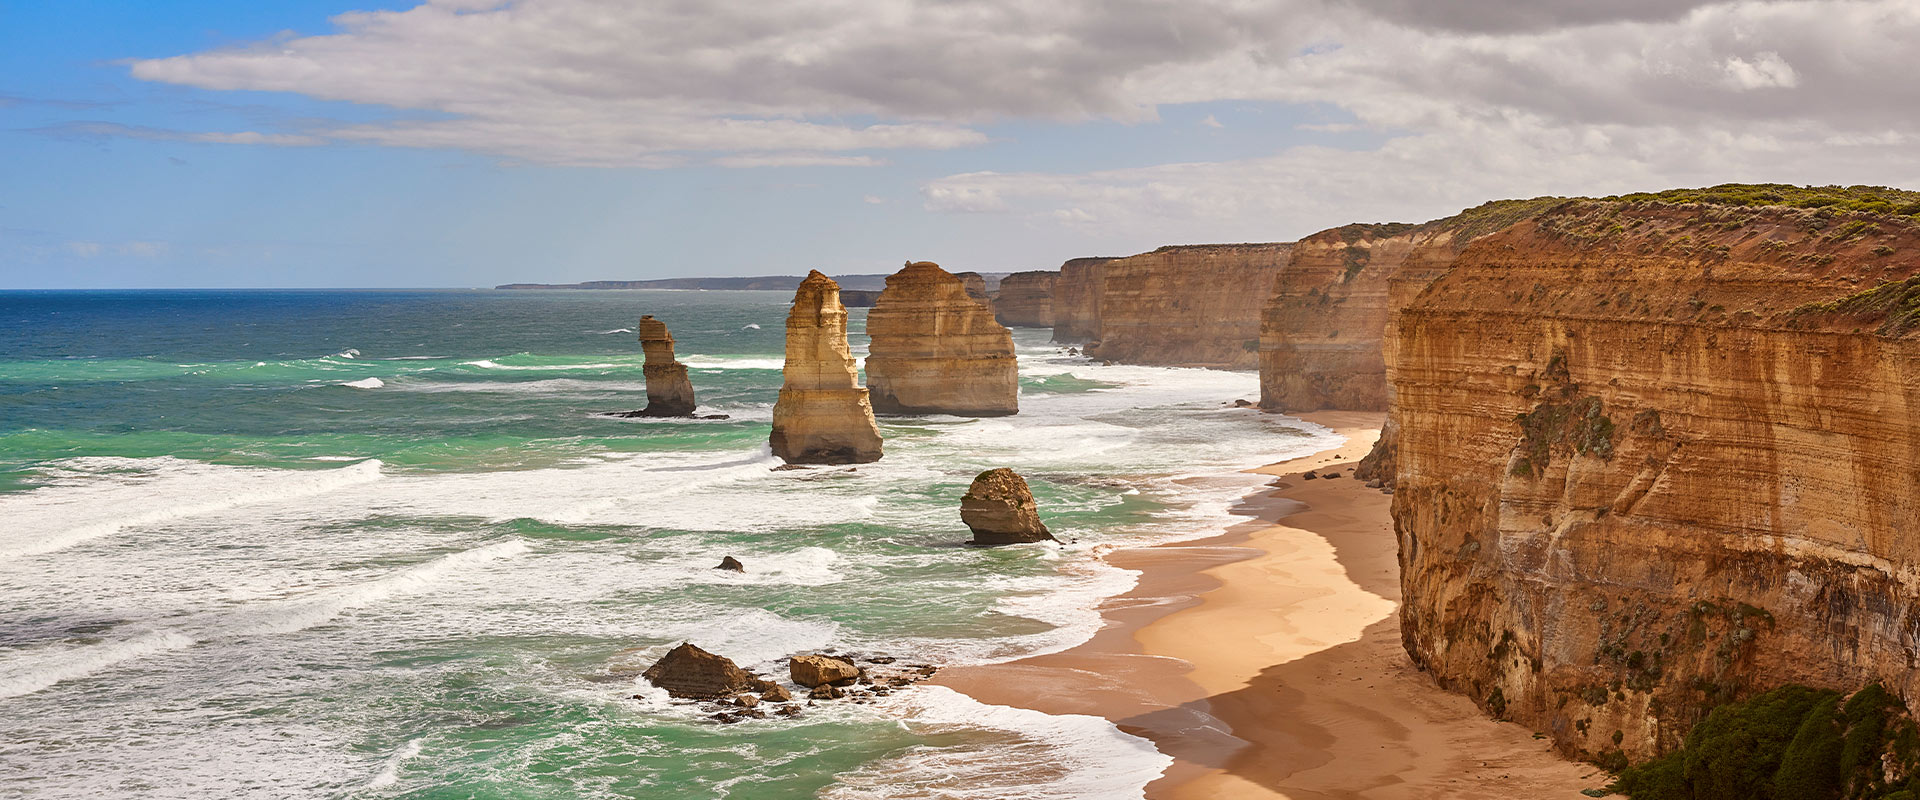Can you elaborate on the elements of the picture provided? This compelling image showcases the Twelve Apostles, a famous natural formation along Victoria, Australia's rugged coast. The Twelve Apostles are towering limestone stacks that rise majestically from the Southern Ocean, carved over millennia by the relentless forces of erosion. What we see are varying hues of orange and tan across the stacks, dramatically contrasted against the vibrant turquoise of the ocean and the foamy white of the breaking waves. Taken from a high viewpoint, the photo offers a sweeping panoramic view that captures the raw beauty of this geological wonder. Beyond its aesthetic appeal, this site holds great ecological and cultural significance, serving as a symbol of natural history and resilience. The cloudy sky, with just a hint of blue, adds a dynamic and somewhat moody atmosphere to the scene, suggesting the unpredictable weather typical of this coastal region. 